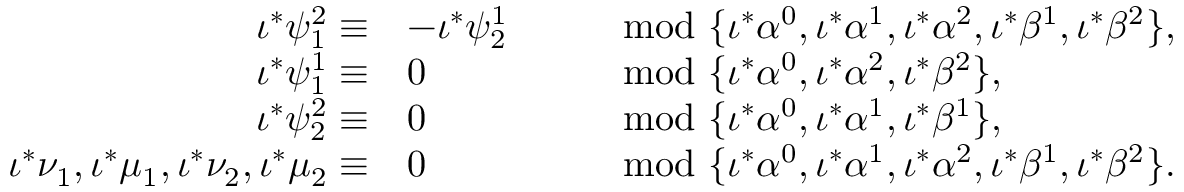<formula> <loc_0><loc_0><loc_500><loc_500>\begin{array} { r l r l } { \iota ^ { * } \psi _ { 1 } ^ { 2 } \equiv } & { - \iota ^ { * } \psi _ { 2 } ^ { 1 } } & & { \mod \{ \iota ^ { * } \alpha ^ { 0 } , \iota ^ { * } \alpha ^ { 1 } , \iota ^ { * } \alpha ^ { 2 } , \iota ^ { * } \beta ^ { 1 } , \iota ^ { * } \beta ^ { 2 } \} , } \\ { \iota ^ { * } \psi _ { 1 } ^ { 1 } \equiv } & { 0 } & & { \mod \{ \iota ^ { * } \alpha ^ { 0 } , \iota ^ { * } \alpha ^ { 2 } , \iota ^ { * } \beta ^ { 2 } \} , } \\ { \iota ^ { * } \psi _ { 2 } ^ { 2 } \equiv } & { 0 } & & { \mod \{ \iota ^ { * } \alpha ^ { 0 } , \iota ^ { * } \alpha ^ { 1 } , \iota ^ { * } \beta ^ { 1 } \} , } \\ { \iota ^ { * } \nu _ { 1 } , \iota ^ { * } \mu _ { 1 } , \iota ^ { * } \nu _ { 2 } , \iota ^ { * } \mu _ { 2 } \equiv } & { 0 } & & { \mod \{ \iota ^ { * } \alpha ^ { 0 } , \iota ^ { * } \alpha ^ { 1 } , \iota ^ { * } \alpha ^ { 2 } , \iota ^ { * } \beta ^ { 1 } , \iota ^ { * } \beta ^ { 2 } \} . } \end{array}</formula> 